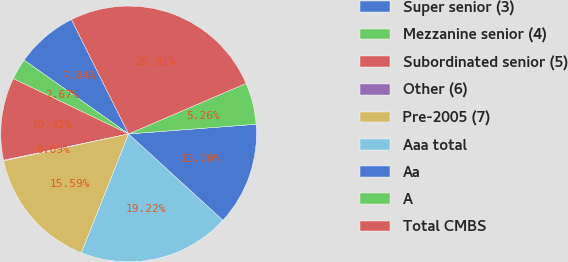Convert chart. <chart><loc_0><loc_0><loc_500><loc_500><pie_chart><fcel>Super senior (3)<fcel>Mezzanine senior (4)<fcel>Subordinated senior (5)<fcel>Other (6)<fcel>Pre-2005 (7)<fcel>Aaa total<fcel>Aa<fcel>A<fcel>Total CMBS<nl><fcel>7.84%<fcel>2.67%<fcel>10.42%<fcel>0.09%<fcel>15.59%<fcel>19.22%<fcel>13.0%<fcel>5.26%<fcel>25.91%<nl></chart> 